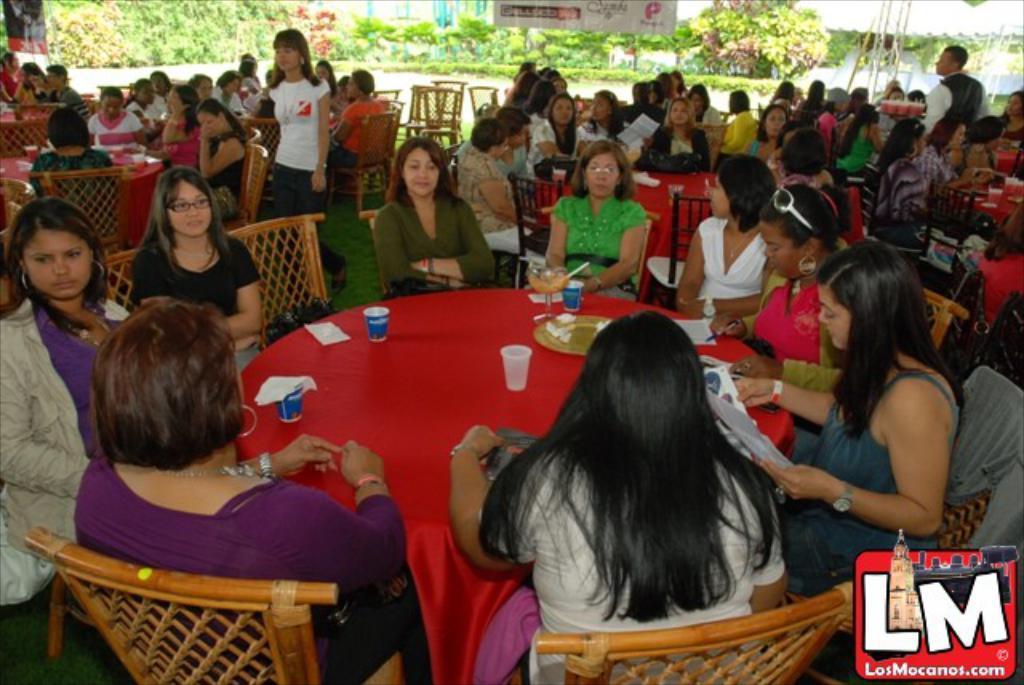Could you give a brief overview of what you see in this image? The picture is taken from a restaurant. In the foreground of the picture there is a table covered with red color cloth and woman seated in chairs, on the table there are glasses, plates and papers. In the background there are many women seated around tables in chairs. On the top of the background there are trees and banners. 